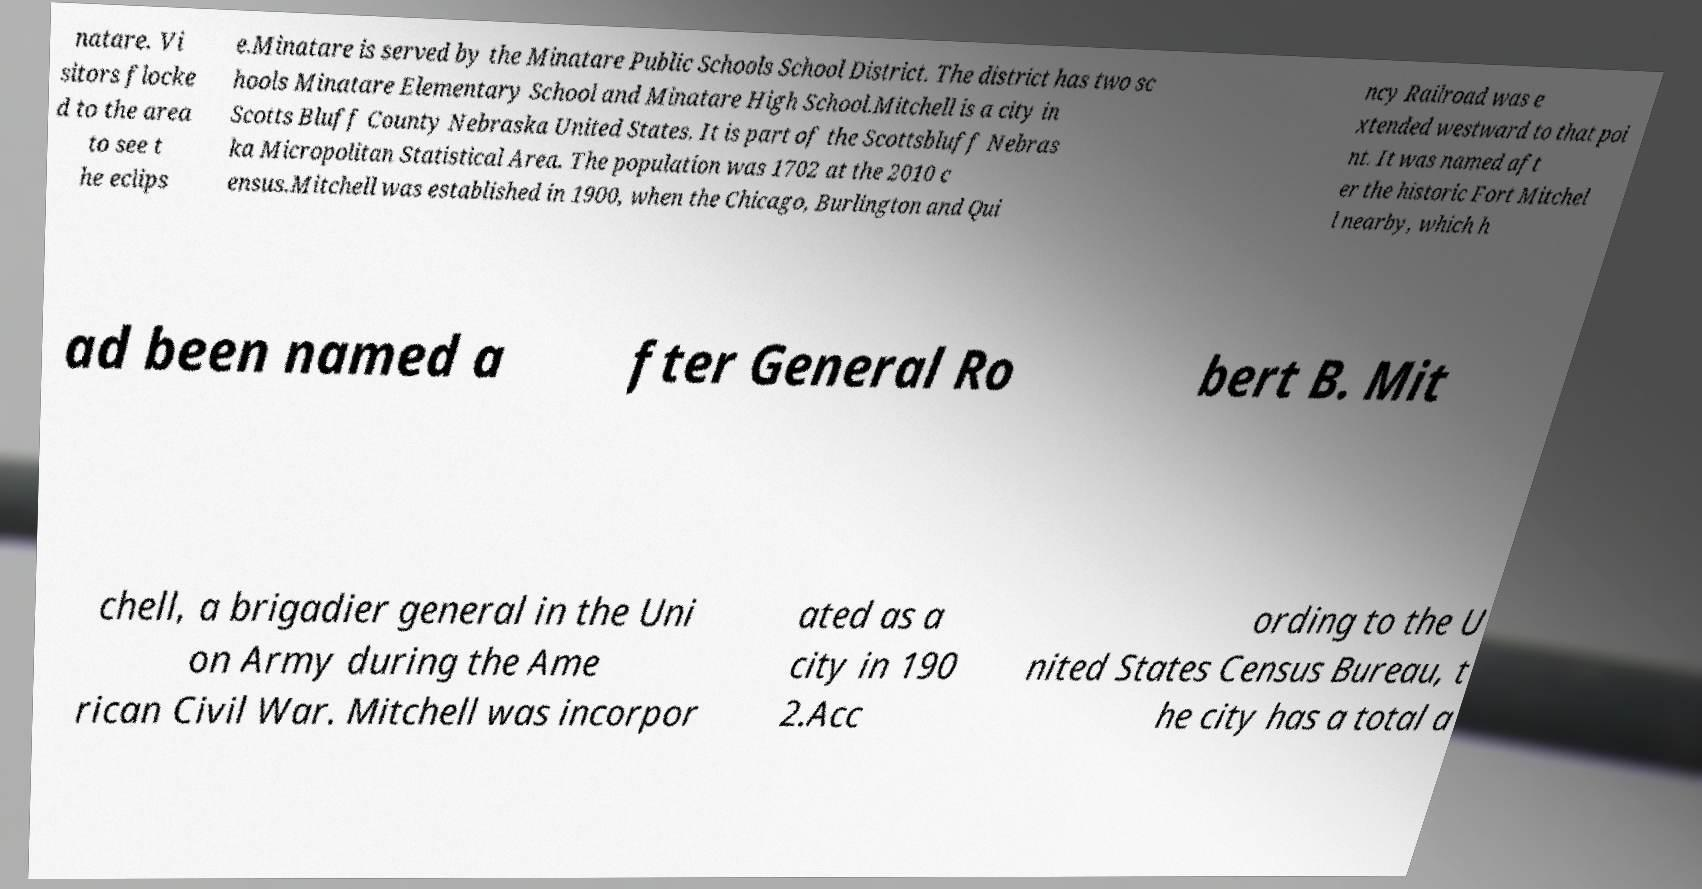I need the written content from this picture converted into text. Can you do that? natare. Vi sitors flocke d to the area to see t he eclips e.Minatare is served by the Minatare Public Schools School District. The district has two sc hools Minatare Elementary School and Minatare High School.Mitchell is a city in Scotts Bluff County Nebraska United States. It is part of the Scottsbluff Nebras ka Micropolitan Statistical Area. The population was 1702 at the 2010 c ensus.Mitchell was established in 1900, when the Chicago, Burlington and Qui ncy Railroad was e xtended westward to that poi nt. It was named aft er the historic Fort Mitchel l nearby, which h ad been named a fter General Ro bert B. Mit chell, a brigadier general in the Uni on Army during the Ame rican Civil War. Mitchell was incorpor ated as a city in 190 2.Acc ording to the U nited States Census Bureau, t he city has a total a 